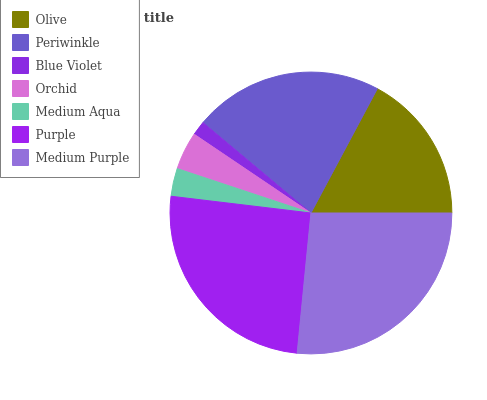Is Blue Violet the minimum?
Answer yes or no. Yes. Is Medium Purple the maximum?
Answer yes or no. Yes. Is Periwinkle the minimum?
Answer yes or no. No. Is Periwinkle the maximum?
Answer yes or no. No. Is Periwinkle greater than Olive?
Answer yes or no. Yes. Is Olive less than Periwinkle?
Answer yes or no. Yes. Is Olive greater than Periwinkle?
Answer yes or no. No. Is Periwinkle less than Olive?
Answer yes or no. No. Is Olive the high median?
Answer yes or no. Yes. Is Olive the low median?
Answer yes or no. Yes. Is Medium Aqua the high median?
Answer yes or no. No. Is Periwinkle the low median?
Answer yes or no. No. 